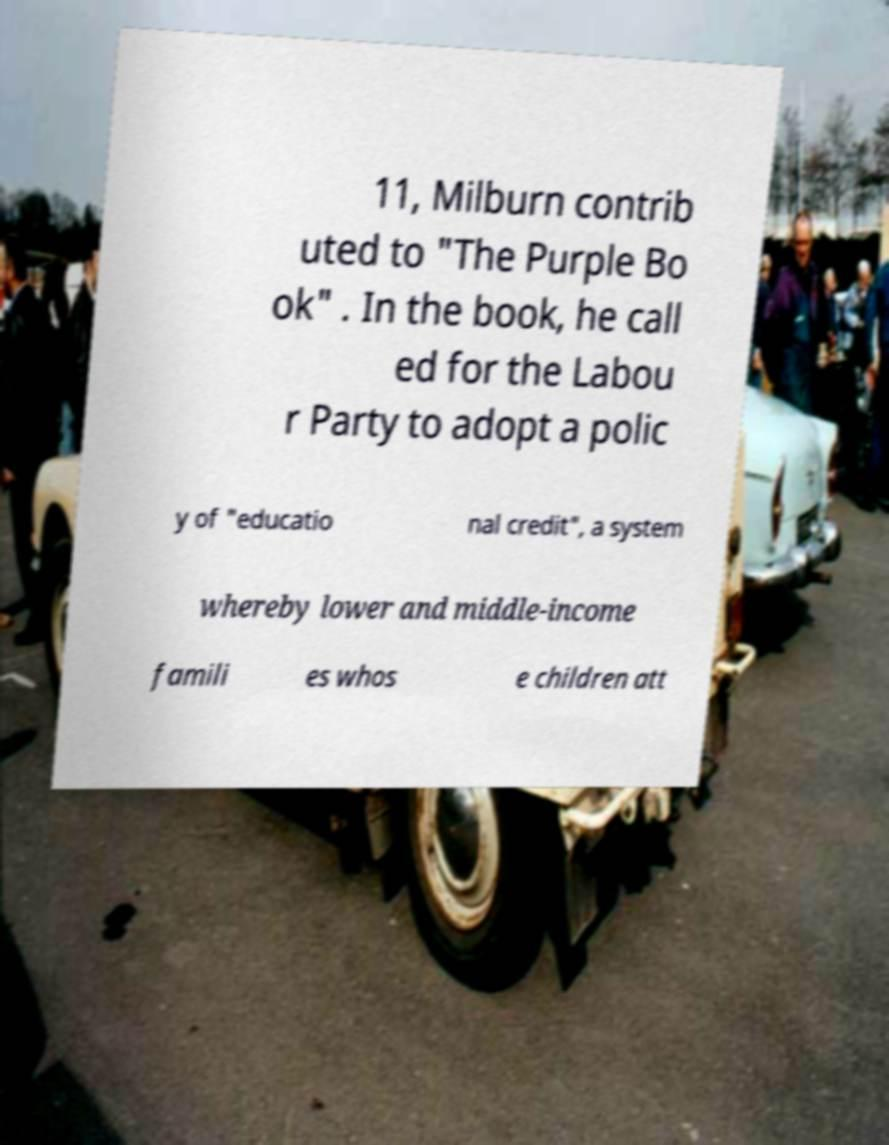Could you extract and type out the text from this image? 11, Milburn contrib uted to "The Purple Bo ok" . In the book, he call ed for the Labou r Party to adopt a polic y of "educatio nal credit", a system whereby lower and middle-income famili es whos e children att 